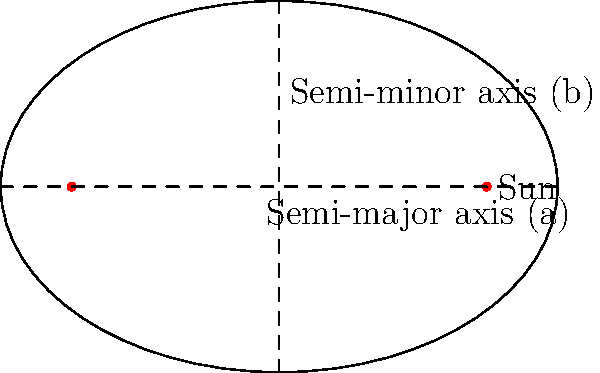As an esports athlete who often incorporates space themes in your branding, you're designing a new logo inspired by planetary orbits. The elliptical orbit shown has a semi-major axis $a=3$ units and a semi-minor axis $b=2$ units. What is the eccentricity $e$ of this orbit, rounded to two decimal places? Let's approach this step-by-step:

1) The eccentricity $e$ of an ellipse is defined as the ratio of the distance between the foci to the length of the major axis. It can be calculated using the formula:

   $$e = \sqrt{1 - \frac{b^2}{a^2}}$$

   Where $a$ is the semi-major axis and $b$ is the semi-minor axis.

2) We are given:
   $a = 3$ units
   $b = 2$ units

3) Let's substitute these values into the formula:

   $$e = \sqrt{1 - \frac{2^2}{3^2}}$$

4) Simplify inside the parentheses:

   $$e = \sqrt{1 - \frac{4}{9}}$$

5) Subtract:

   $$e = \sqrt{\frac{5}{9}}$$

6) Calculate the square root:

   $$e \approx 0.7454$$

7) Rounding to two decimal places:

   $$e \approx 0.75$$

This eccentricity value indicates that the orbit is moderately elliptical, which could create an interesting and dynamic logo design.
Answer: 0.75 